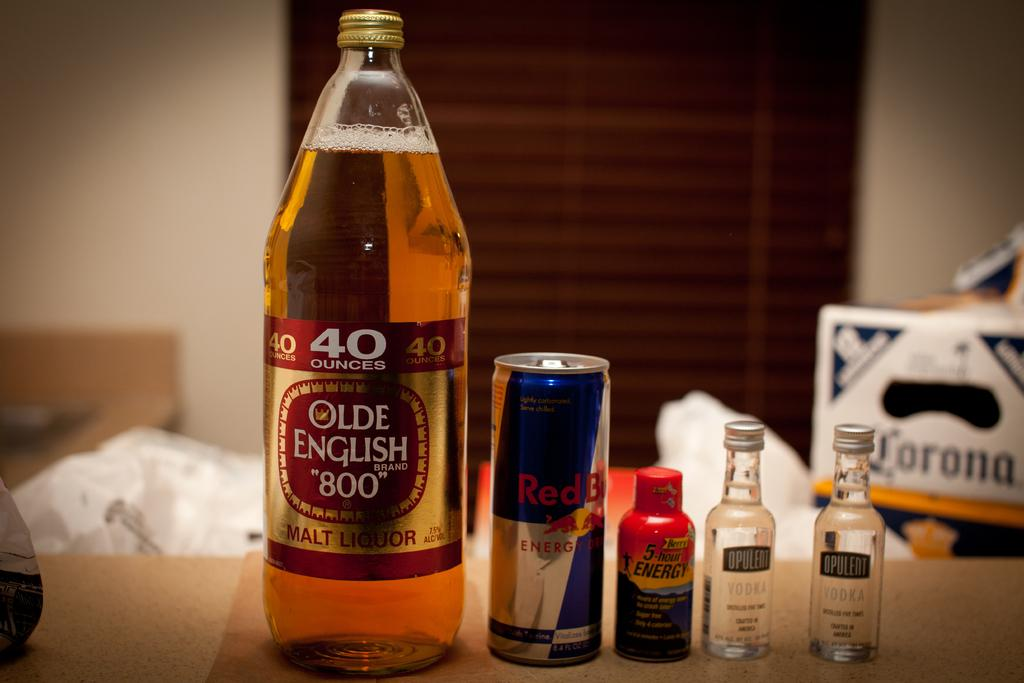<image>
Share a concise interpretation of the image provided. Forty ounce of Olde English 800 malt liquor, a can of red bull, bottle of 5 hour energy and two small vodka bottles lined up on a counter. 